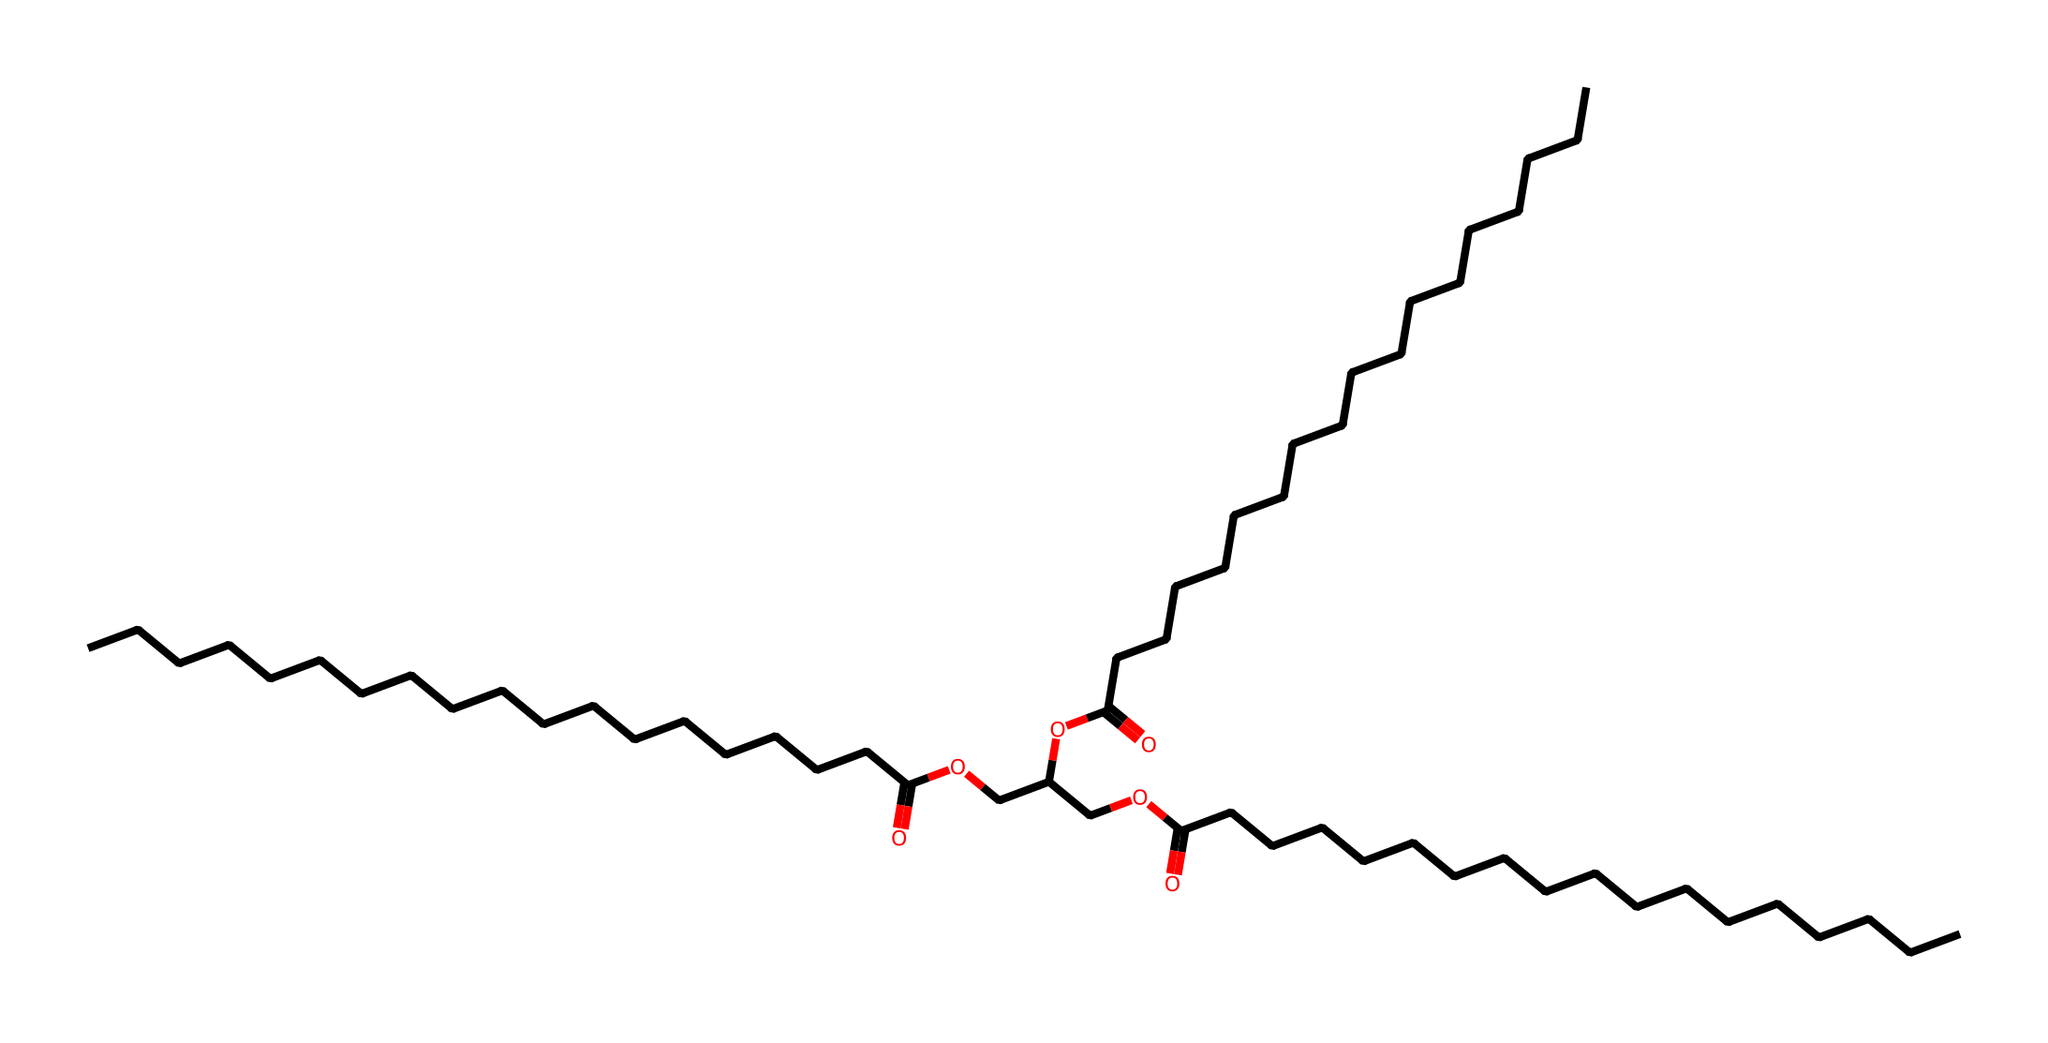What type of functional group is present in this chemical? The chemical contains a carboxylic acid functional group, as evidenced by the presence of the -COOH group. This can be identified from the carbonyl (C=O) bonded to a hydroxyl (-OH) group.
Answer: carboxylic acid How many carbon atoms are in the longest carbon chain? By analyzing the structure, the longest continuous chain of carbon atoms is determined by tracing the carbon (C) atoms in the chemical's backbone. There are primarily 18 carbon atoms in the longest chain observed.
Answer: 18 What is the primary use of this chemical? Given that the structure is a complex ester with long carbon chains, it is designed for lubrication purposes, specifically for synthetic oil in vintage car maintenance.
Answer: lubrication What type of chemical is this synthesized from? The structure includes ester linkages and carboxylic acid functional groups, indicating that it is synthesized from fatty acids and alcohols. These components are common in the production of synthetic lubricants.
Answer: fatty acids and alcohols What characteristic property does this chemical exhibit due to its long carbon chains? The long carbon chains result in increased viscosity, which is crucial for maintaining proper lubrication in vintage cars to reduce friction and wear.
Answer: increased viscosity 